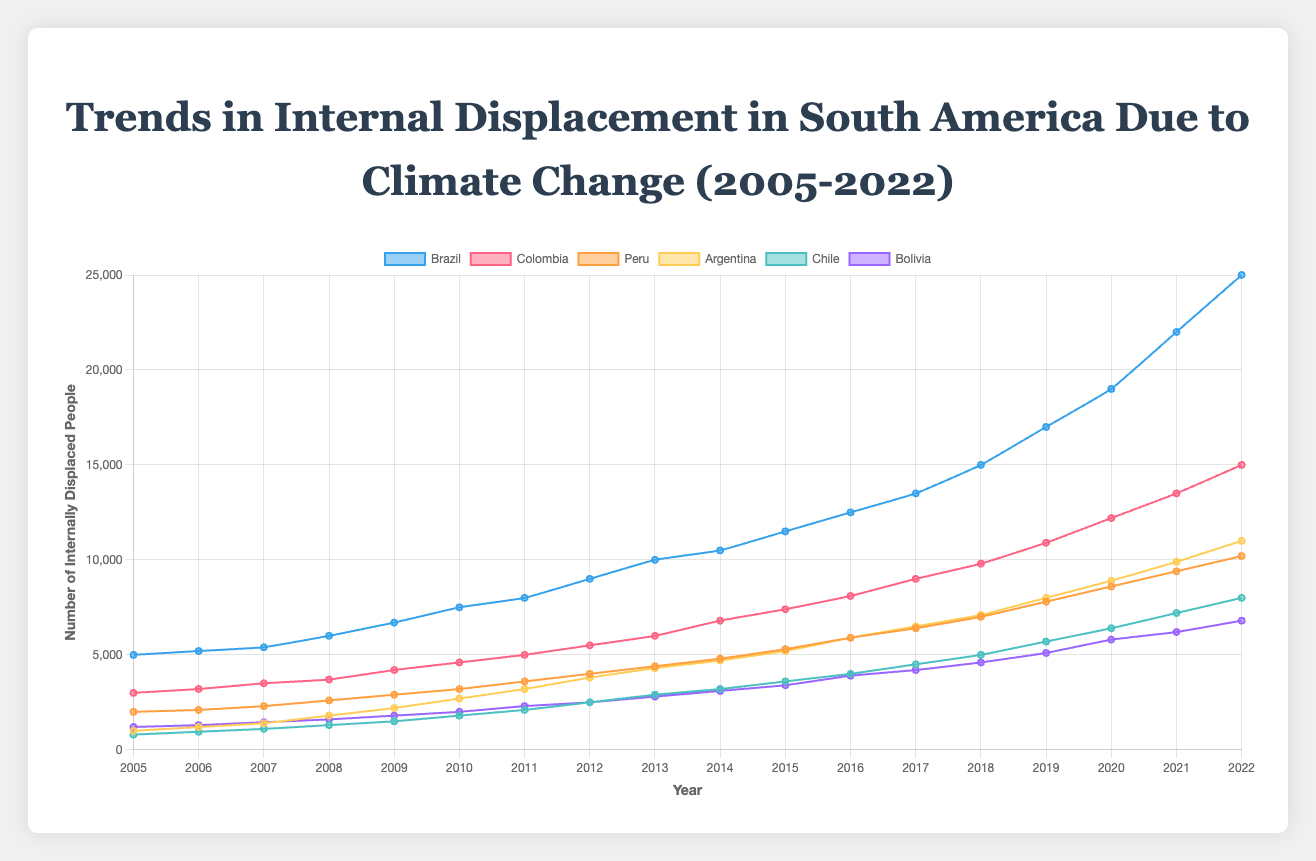Which country has the highest number of internally displaced people in 2022? To determine this, look at the endpoint of each line on the y-axis in 2022. The highest point indicates the country with the most internally displaced people.
Answer: Brazil How much did the number of internally displaced people increase in Colombia from 2010 to 2020? First, note the values for Colombia in 2010 and 2020. The numbers are 4600 and 12200, respectively. Subtract the 2010 value from the 2020 value to find the increase. 12200 - 4600 = 7600
Answer: 7600 Which two countries had the smallest difference in internally displaced people in 2018? Look at the 2018 values for all countries and find the two with the smallest numerical difference. Brazil has 15000 and Colombia has 9800. The differences with other countries are higher than 5000 (Chile: 4600; Peru: 7000; Bolivia: 4600; Argentina: 7100). Nevertheless, by observing the pattern, Peru (7000) and Argentina (7100) have the smallest difference of approximately 100.
Answer: Argentina and Peru What is the average number of internally displaced people in Bolivia from 2005 to 2022? To compute the average, add all the yearly values for Bolivia from 2005 to 2022, then divide by the number of years (18). Sum is 68900, average is 68900 / 18 = 3827.78
Answer: 3827.78 How does the trend in Argentina’s internally displaced people compare between 2010 and 2022? Note the values for Argentina in 2010 (2700) and 2022 (11000). To describe the trend, calculate the difference and assess whether the increase is steady. The increase from 2700 to 11000 indicates a rising trend.
Answer: Increasing trend What is the median number of internally displaced people in Chile over the given period? List the values for Chile from 2005 to 2022: [800, 950, 1100, 1300, 1500, 1800, 2100, 2500, 2900, 3200, 3600, 4000, 4500, 5000, 5700, 6400, 7200, 8000]. The median is the middle value in this ordered list, which is the average of the 9th and 10th values (2900 and 3200). Thus, (2900 + 3200) / 2 = 3050.
Answer: 3050 Which country showed the smallest increase in internally displaced people from 2005 to 2022? Identify the initial (2005) and final (2022) values for each country and calculate the increase for each. The increases are: Brazil (20000), Colombia (12000), Peru (8200), Argentina (10000), Chile (7200), Bolivia (5600). The smallest increase is for Bolivia, which is 5600.
Answer: Bolivia Between 2017 and 2022, which country had the highest growth rate in internally displaced people? Calculate the growth rate for each country using the formula (value in 2022 - value in 2017) / value in 2017. The growth rates are: Brazil ((25000 - 13500) / 13500 = 0.85), Colombia ((15000 - 9000) / 9000 = 0.67), Peru ((10200 - 6400) / 6400 = 0.59), Argentina ((11000 - 6500) / 6500 = 0.69), Chile ((8000 - 4500) / 4500 = 0.78), Bolivia ((6800 - 4200) / 4200 = 0.62). Brazil has the highest growth rate of 0.85.
Answer: Brazil 